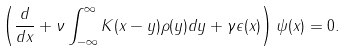<formula> <loc_0><loc_0><loc_500><loc_500>\left ( \frac { d } { d x } + \nu \int _ { - \infty } ^ { \infty } K ( x - y ) \rho ( y ) d y + \gamma \epsilon ( x ) \right ) \psi ( x ) = 0 .</formula> 